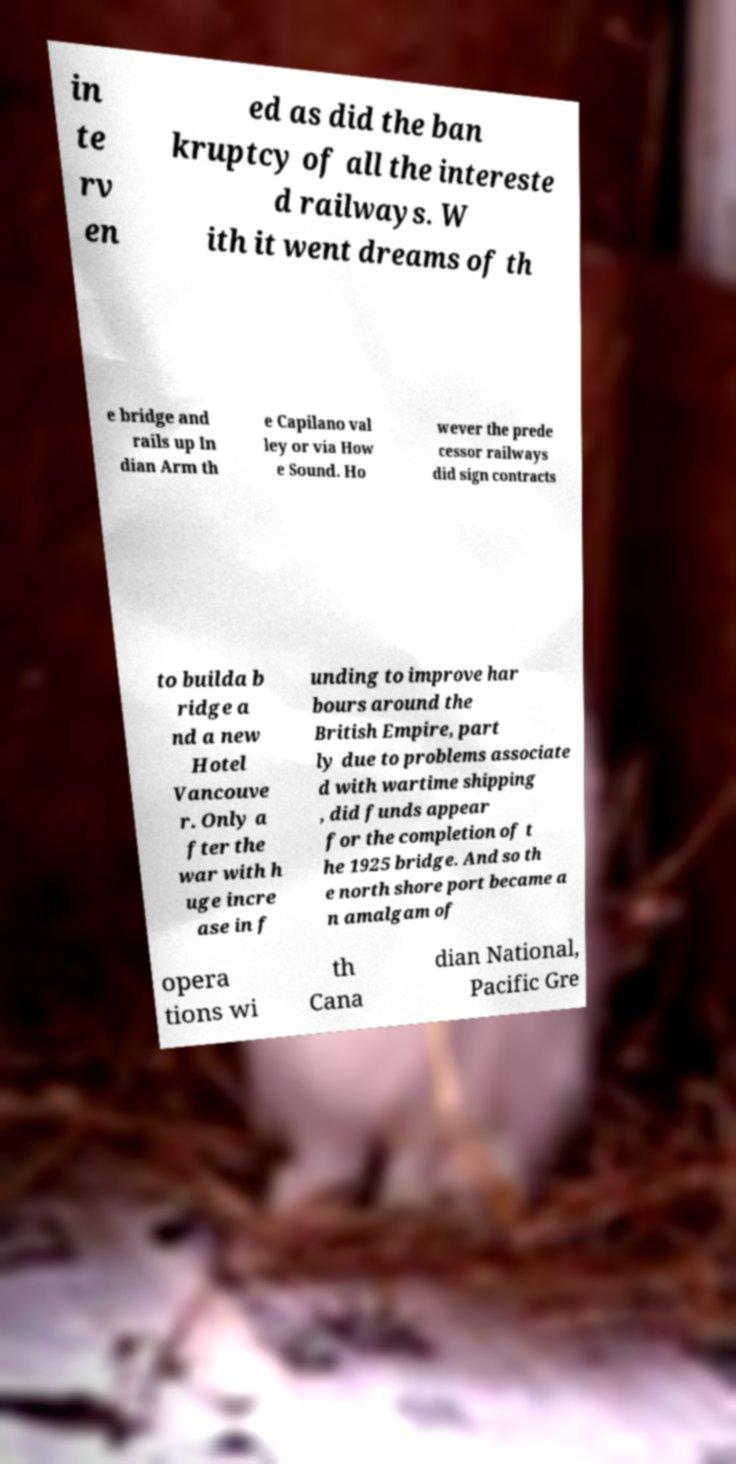There's text embedded in this image that I need extracted. Can you transcribe it verbatim? in te rv en ed as did the ban kruptcy of all the intereste d railways. W ith it went dreams of th e bridge and rails up In dian Arm th e Capilano val ley or via How e Sound. Ho wever the prede cessor railways did sign contracts to builda b ridge a nd a new Hotel Vancouve r. Only a fter the war with h uge incre ase in f unding to improve har bours around the British Empire, part ly due to problems associate d with wartime shipping , did funds appear for the completion of t he 1925 bridge. And so th e north shore port became a n amalgam of opera tions wi th Cana dian National, Pacific Gre 